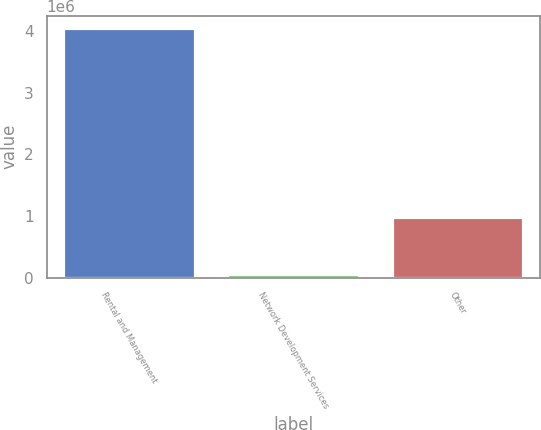Convert chart to OTSL. <chart><loc_0><loc_0><loc_500><loc_500><bar_chart><fcel>Rental and Management<fcel>Network Development Services<fcel>Other<nl><fcel>4.0507e+06<fcel>55294<fcel>979975<nl></chart> 